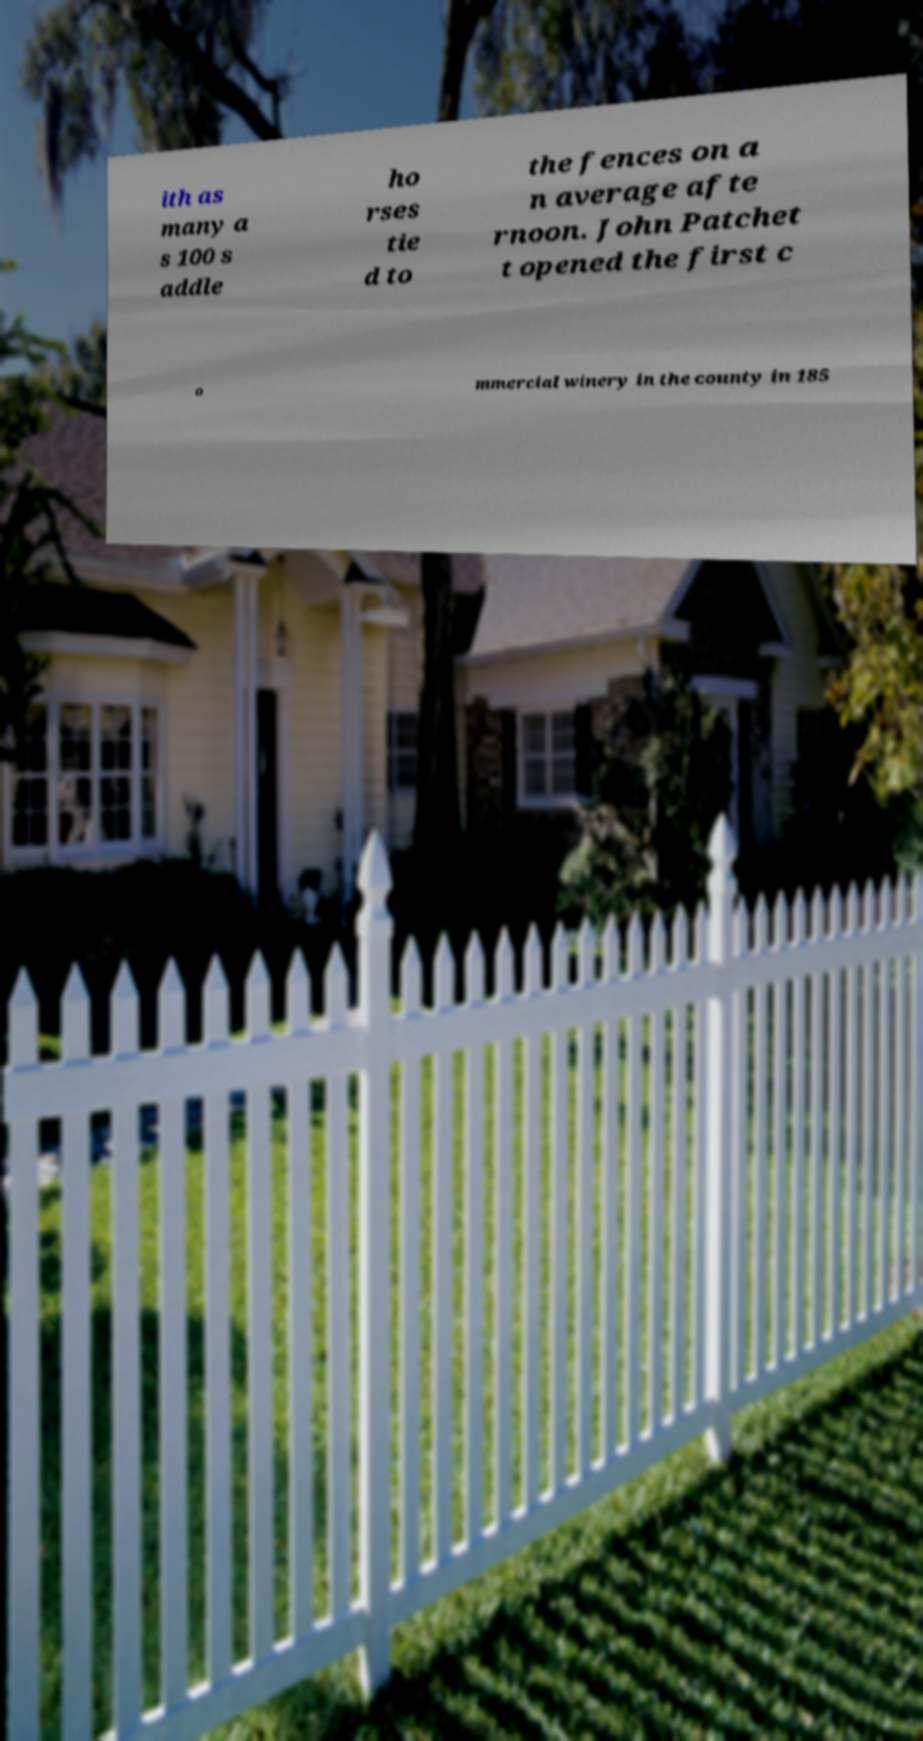Can you accurately transcribe the text from the provided image for me? ith as many a s 100 s addle ho rses tie d to the fences on a n average afte rnoon. John Patchet t opened the first c o mmercial winery in the county in 185 